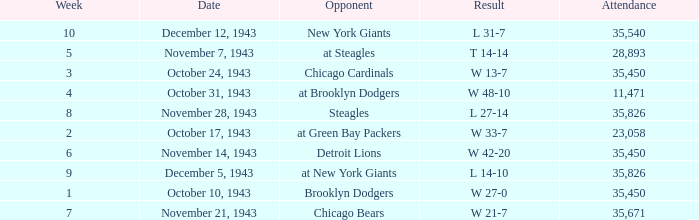How many attendances have 9 as the week? 1.0. 